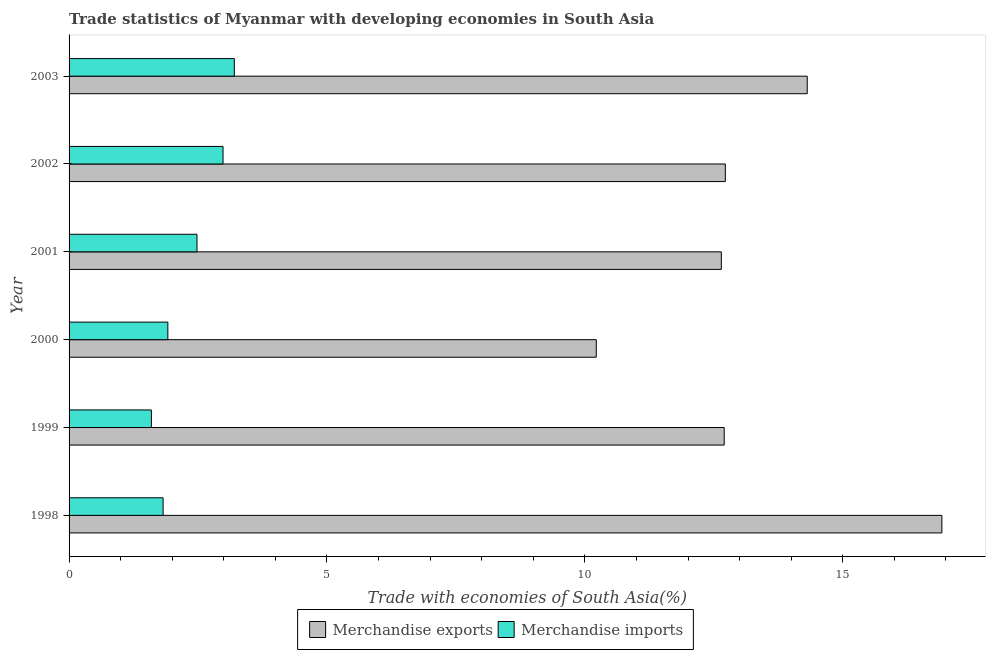How many different coloured bars are there?
Ensure brevity in your answer.  2. How many groups of bars are there?
Offer a very short reply. 6. Are the number of bars per tick equal to the number of legend labels?
Your answer should be compact. Yes. How many bars are there on the 4th tick from the top?
Give a very brief answer. 2. How many bars are there on the 5th tick from the bottom?
Make the answer very short. 2. What is the merchandise exports in 2003?
Provide a succinct answer. 14.31. Across all years, what is the maximum merchandise exports?
Make the answer very short. 16.92. Across all years, what is the minimum merchandise imports?
Your answer should be compact. 1.6. What is the total merchandise exports in the graph?
Provide a succinct answer. 79.52. What is the difference between the merchandise imports in 2001 and that in 2002?
Your answer should be compact. -0.51. What is the difference between the merchandise imports in 2002 and the merchandise exports in 1999?
Keep it short and to the point. -9.72. What is the average merchandise imports per year?
Your response must be concise. 2.33. In the year 2001, what is the difference between the merchandise imports and merchandise exports?
Keep it short and to the point. -10.17. In how many years, is the merchandise imports greater than 16 %?
Provide a succinct answer. 0. What is the ratio of the merchandise exports in 1998 to that in 2002?
Your answer should be compact. 1.33. Is the merchandise imports in 2001 less than that in 2003?
Give a very brief answer. Yes. What is the difference between the highest and the second highest merchandise imports?
Ensure brevity in your answer.  0.22. What is the difference between the highest and the lowest merchandise imports?
Ensure brevity in your answer.  1.61. Is the sum of the merchandise imports in 2001 and 2003 greater than the maximum merchandise exports across all years?
Make the answer very short. No. What does the 2nd bar from the top in 1998 represents?
Give a very brief answer. Merchandise exports. What does the 1st bar from the bottom in 2001 represents?
Your response must be concise. Merchandise exports. How many years are there in the graph?
Provide a short and direct response. 6. Does the graph contain any zero values?
Make the answer very short. No. Where does the legend appear in the graph?
Offer a very short reply. Bottom center. How are the legend labels stacked?
Offer a terse response. Horizontal. What is the title of the graph?
Provide a succinct answer. Trade statistics of Myanmar with developing economies in South Asia. Does "Techinal cooperation" appear as one of the legend labels in the graph?
Your answer should be compact. No. What is the label or title of the X-axis?
Provide a short and direct response. Trade with economies of South Asia(%). What is the Trade with economies of South Asia(%) of Merchandise exports in 1998?
Provide a short and direct response. 16.92. What is the Trade with economies of South Asia(%) of Merchandise imports in 1998?
Provide a short and direct response. 1.82. What is the Trade with economies of South Asia(%) in Merchandise exports in 1999?
Make the answer very short. 12.7. What is the Trade with economies of South Asia(%) in Merchandise imports in 1999?
Offer a terse response. 1.6. What is the Trade with economies of South Asia(%) of Merchandise exports in 2000?
Your answer should be compact. 10.22. What is the Trade with economies of South Asia(%) of Merchandise imports in 2000?
Keep it short and to the point. 1.92. What is the Trade with economies of South Asia(%) in Merchandise exports in 2001?
Provide a succinct answer. 12.65. What is the Trade with economies of South Asia(%) of Merchandise imports in 2001?
Offer a very short reply. 2.48. What is the Trade with economies of South Asia(%) of Merchandise exports in 2002?
Offer a terse response. 12.72. What is the Trade with economies of South Asia(%) of Merchandise imports in 2002?
Make the answer very short. 2.98. What is the Trade with economies of South Asia(%) of Merchandise exports in 2003?
Give a very brief answer. 14.31. What is the Trade with economies of South Asia(%) in Merchandise imports in 2003?
Give a very brief answer. 3.2. Across all years, what is the maximum Trade with economies of South Asia(%) of Merchandise exports?
Provide a succinct answer. 16.92. Across all years, what is the maximum Trade with economies of South Asia(%) in Merchandise imports?
Your answer should be very brief. 3.2. Across all years, what is the minimum Trade with economies of South Asia(%) of Merchandise exports?
Offer a terse response. 10.22. Across all years, what is the minimum Trade with economies of South Asia(%) in Merchandise imports?
Provide a succinct answer. 1.6. What is the total Trade with economies of South Asia(%) in Merchandise exports in the graph?
Offer a terse response. 79.53. What is the total Trade with economies of South Asia(%) of Merchandise imports in the graph?
Offer a very short reply. 14. What is the difference between the Trade with economies of South Asia(%) in Merchandise exports in 1998 and that in 1999?
Make the answer very short. 4.22. What is the difference between the Trade with economies of South Asia(%) in Merchandise imports in 1998 and that in 1999?
Provide a short and direct response. 0.23. What is the difference between the Trade with economies of South Asia(%) of Merchandise exports in 1998 and that in 2000?
Provide a short and direct response. 6.7. What is the difference between the Trade with economies of South Asia(%) of Merchandise imports in 1998 and that in 2000?
Keep it short and to the point. -0.09. What is the difference between the Trade with economies of South Asia(%) in Merchandise exports in 1998 and that in 2001?
Give a very brief answer. 4.28. What is the difference between the Trade with economies of South Asia(%) in Merchandise imports in 1998 and that in 2001?
Offer a very short reply. -0.66. What is the difference between the Trade with economies of South Asia(%) in Merchandise exports in 1998 and that in 2002?
Keep it short and to the point. 4.2. What is the difference between the Trade with economies of South Asia(%) in Merchandise imports in 1998 and that in 2002?
Keep it short and to the point. -1.16. What is the difference between the Trade with economies of South Asia(%) of Merchandise exports in 1998 and that in 2003?
Your response must be concise. 2.61. What is the difference between the Trade with economies of South Asia(%) in Merchandise imports in 1998 and that in 2003?
Your answer should be compact. -1.38. What is the difference between the Trade with economies of South Asia(%) in Merchandise exports in 1999 and that in 2000?
Offer a very short reply. 2.48. What is the difference between the Trade with economies of South Asia(%) in Merchandise imports in 1999 and that in 2000?
Offer a very short reply. -0.32. What is the difference between the Trade with economies of South Asia(%) of Merchandise exports in 1999 and that in 2001?
Provide a short and direct response. 0.06. What is the difference between the Trade with economies of South Asia(%) of Merchandise imports in 1999 and that in 2001?
Your answer should be very brief. -0.88. What is the difference between the Trade with economies of South Asia(%) in Merchandise exports in 1999 and that in 2002?
Your response must be concise. -0.02. What is the difference between the Trade with economies of South Asia(%) of Merchandise imports in 1999 and that in 2002?
Keep it short and to the point. -1.39. What is the difference between the Trade with economies of South Asia(%) of Merchandise exports in 1999 and that in 2003?
Your response must be concise. -1.61. What is the difference between the Trade with economies of South Asia(%) in Merchandise imports in 1999 and that in 2003?
Provide a short and direct response. -1.61. What is the difference between the Trade with economies of South Asia(%) of Merchandise exports in 2000 and that in 2001?
Offer a terse response. -2.42. What is the difference between the Trade with economies of South Asia(%) of Merchandise imports in 2000 and that in 2001?
Ensure brevity in your answer.  -0.56. What is the difference between the Trade with economies of South Asia(%) of Merchandise exports in 2000 and that in 2002?
Provide a short and direct response. -2.5. What is the difference between the Trade with economies of South Asia(%) in Merchandise imports in 2000 and that in 2002?
Give a very brief answer. -1.07. What is the difference between the Trade with economies of South Asia(%) of Merchandise exports in 2000 and that in 2003?
Provide a succinct answer. -4.09. What is the difference between the Trade with economies of South Asia(%) of Merchandise imports in 2000 and that in 2003?
Ensure brevity in your answer.  -1.29. What is the difference between the Trade with economies of South Asia(%) of Merchandise exports in 2001 and that in 2002?
Provide a succinct answer. -0.08. What is the difference between the Trade with economies of South Asia(%) in Merchandise imports in 2001 and that in 2002?
Give a very brief answer. -0.51. What is the difference between the Trade with economies of South Asia(%) of Merchandise exports in 2001 and that in 2003?
Offer a very short reply. -1.67. What is the difference between the Trade with economies of South Asia(%) of Merchandise imports in 2001 and that in 2003?
Offer a very short reply. -0.72. What is the difference between the Trade with economies of South Asia(%) in Merchandise exports in 2002 and that in 2003?
Keep it short and to the point. -1.59. What is the difference between the Trade with economies of South Asia(%) of Merchandise imports in 2002 and that in 2003?
Your answer should be very brief. -0.22. What is the difference between the Trade with economies of South Asia(%) in Merchandise exports in 1998 and the Trade with economies of South Asia(%) in Merchandise imports in 1999?
Keep it short and to the point. 15.33. What is the difference between the Trade with economies of South Asia(%) of Merchandise exports in 1998 and the Trade with economies of South Asia(%) of Merchandise imports in 2000?
Ensure brevity in your answer.  15.01. What is the difference between the Trade with economies of South Asia(%) of Merchandise exports in 1998 and the Trade with economies of South Asia(%) of Merchandise imports in 2001?
Your response must be concise. 14.44. What is the difference between the Trade with economies of South Asia(%) of Merchandise exports in 1998 and the Trade with economies of South Asia(%) of Merchandise imports in 2002?
Provide a short and direct response. 13.94. What is the difference between the Trade with economies of South Asia(%) of Merchandise exports in 1998 and the Trade with economies of South Asia(%) of Merchandise imports in 2003?
Offer a very short reply. 13.72. What is the difference between the Trade with economies of South Asia(%) of Merchandise exports in 1999 and the Trade with economies of South Asia(%) of Merchandise imports in 2000?
Offer a very short reply. 10.79. What is the difference between the Trade with economies of South Asia(%) of Merchandise exports in 1999 and the Trade with economies of South Asia(%) of Merchandise imports in 2001?
Your answer should be compact. 10.22. What is the difference between the Trade with economies of South Asia(%) of Merchandise exports in 1999 and the Trade with economies of South Asia(%) of Merchandise imports in 2002?
Provide a succinct answer. 9.72. What is the difference between the Trade with economies of South Asia(%) of Merchandise exports in 1999 and the Trade with economies of South Asia(%) of Merchandise imports in 2003?
Your answer should be very brief. 9.5. What is the difference between the Trade with economies of South Asia(%) of Merchandise exports in 2000 and the Trade with economies of South Asia(%) of Merchandise imports in 2001?
Your answer should be compact. 7.74. What is the difference between the Trade with economies of South Asia(%) in Merchandise exports in 2000 and the Trade with economies of South Asia(%) in Merchandise imports in 2002?
Your response must be concise. 7.24. What is the difference between the Trade with economies of South Asia(%) in Merchandise exports in 2000 and the Trade with economies of South Asia(%) in Merchandise imports in 2003?
Your answer should be compact. 7.02. What is the difference between the Trade with economies of South Asia(%) in Merchandise exports in 2001 and the Trade with economies of South Asia(%) in Merchandise imports in 2002?
Keep it short and to the point. 9.66. What is the difference between the Trade with economies of South Asia(%) in Merchandise exports in 2001 and the Trade with economies of South Asia(%) in Merchandise imports in 2003?
Make the answer very short. 9.44. What is the difference between the Trade with economies of South Asia(%) in Merchandise exports in 2002 and the Trade with economies of South Asia(%) in Merchandise imports in 2003?
Your answer should be very brief. 9.52. What is the average Trade with economies of South Asia(%) in Merchandise exports per year?
Make the answer very short. 13.25. What is the average Trade with economies of South Asia(%) of Merchandise imports per year?
Make the answer very short. 2.33. In the year 1998, what is the difference between the Trade with economies of South Asia(%) in Merchandise exports and Trade with economies of South Asia(%) in Merchandise imports?
Make the answer very short. 15.1. In the year 1999, what is the difference between the Trade with economies of South Asia(%) in Merchandise exports and Trade with economies of South Asia(%) in Merchandise imports?
Provide a succinct answer. 11.11. In the year 2000, what is the difference between the Trade with economies of South Asia(%) of Merchandise exports and Trade with economies of South Asia(%) of Merchandise imports?
Your answer should be compact. 8.31. In the year 2001, what is the difference between the Trade with economies of South Asia(%) of Merchandise exports and Trade with economies of South Asia(%) of Merchandise imports?
Provide a succinct answer. 10.17. In the year 2002, what is the difference between the Trade with economies of South Asia(%) in Merchandise exports and Trade with economies of South Asia(%) in Merchandise imports?
Offer a very short reply. 9.74. In the year 2003, what is the difference between the Trade with economies of South Asia(%) in Merchandise exports and Trade with economies of South Asia(%) in Merchandise imports?
Keep it short and to the point. 11.11. What is the ratio of the Trade with economies of South Asia(%) of Merchandise exports in 1998 to that in 1999?
Provide a short and direct response. 1.33. What is the ratio of the Trade with economies of South Asia(%) of Merchandise imports in 1998 to that in 1999?
Your response must be concise. 1.14. What is the ratio of the Trade with economies of South Asia(%) in Merchandise exports in 1998 to that in 2000?
Keep it short and to the point. 1.66. What is the ratio of the Trade with economies of South Asia(%) in Merchandise imports in 1998 to that in 2000?
Provide a short and direct response. 0.95. What is the ratio of the Trade with economies of South Asia(%) of Merchandise exports in 1998 to that in 2001?
Offer a very short reply. 1.34. What is the ratio of the Trade with economies of South Asia(%) in Merchandise imports in 1998 to that in 2001?
Your response must be concise. 0.74. What is the ratio of the Trade with economies of South Asia(%) of Merchandise exports in 1998 to that in 2002?
Your answer should be very brief. 1.33. What is the ratio of the Trade with economies of South Asia(%) in Merchandise imports in 1998 to that in 2002?
Offer a terse response. 0.61. What is the ratio of the Trade with economies of South Asia(%) in Merchandise exports in 1998 to that in 2003?
Provide a succinct answer. 1.18. What is the ratio of the Trade with economies of South Asia(%) of Merchandise imports in 1998 to that in 2003?
Offer a very short reply. 0.57. What is the ratio of the Trade with economies of South Asia(%) in Merchandise exports in 1999 to that in 2000?
Ensure brevity in your answer.  1.24. What is the ratio of the Trade with economies of South Asia(%) in Merchandise imports in 1999 to that in 2000?
Your answer should be very brief. 0.83. What is the ratio of the Trade with economies of South Asia(%) of Merchandise imports in 1999 to that in 2001?
Offer a terse response. 0.64. What is the ratio of the Trade with economies of South Asia(%) in Merchandise exports in 1999 to that in 2002?
Your answer should be compact. 1. What is the ratio of the Trade with economies of South Asia(%) of Merchandise imports in 1999 to that in 2002?
Provide a succinct answer. 0.53. What is the ratio of the Trade with economies of South Asia(%) in Merchandise exports in 1999 to that in 2003?
Your response must be concise. 0.89. What is the ratio of the Trade with economies of South Asia(%) of Merchandise imports in 1999 to that in 2003?
Your answer should be compact. 0.5. What is the ratio of the Trade with economies of South Asia(%) of Merchandise exports in 2000 to that in 2001?
Your answer should be compact. 0.81. What is the ratio of the Trade with economies of South Asia(%) in Merchandise imports in 2000 to that in 2001?
Offer a very short reply. 0.77. What is the ratio of the Trade with economies of South Asia(%) of Merchandise exports in 2000 to that in 2002?
Make the answer very short. 0.8. What is the ratio of the Trade with economies of South Asia(%) in Merchandise imports in 2000 to that in 2002?
Offer a very short reply. 0.64. What is the ratio of the Trade with economies of South Asia(%) of Merchandise exports in 2000 to that in 2003?
Ensure brevity in your answer.  0.71. What is the ratio of the Trade with economies of South Asia(%) in Merchandise imports in 2000 to that in 2003?
Offer a very short reply. 0.6. What is the ratio of the Trade with economies of South Asia(%) of Merchandise exports in 2001 to that in 2002?
Provide a succinct answer. 0.99. What is the ratio of the Trade with economies of South Asia(%) of Merchandise imports in 2001 to that in 2002?
Provide a short and direct response. 0.83. What is the ratio of the Trade with economies of South Asia(%) of Merchandise exports in 2001 to that in 2003?
Offer a terse response. 0.88. What is the ratio of the Trade with economies of South Asia(%) of Merchandise imports in 2001 to that in 2003?
Your answer should be very brief. 0.77. What is the ratio of the Trade with economies of South Asia(%) in Merchandise exports in 2002 to that in 2003?
Your response must be concise. 0.89. What is the ratio of the Trade with economies of South Asia(%) of Merchandise imports in 2002 to that in 2003?
Ensure brevity in your answer.  0.93. What is the difference between the highest and the second highest Trade with economies of South Asia(%) in Merchandise exports?
Ensure brevity in your answer.  2.61. What is the difference between the highest and the second highest Trade with economies of South Asia(%) in Merchandise imports?
Provide a short and direct response. 0.22. What is the difference between the highest and the lowest Trade with economies of South Asia(%) in Merchandise exports?
Offer a very short reply. 6.7. What is the difference between the highest and the lowest Trade with economies of South Asia(%) in Merchandise imports?
Offer a very short reply. 1.61. 